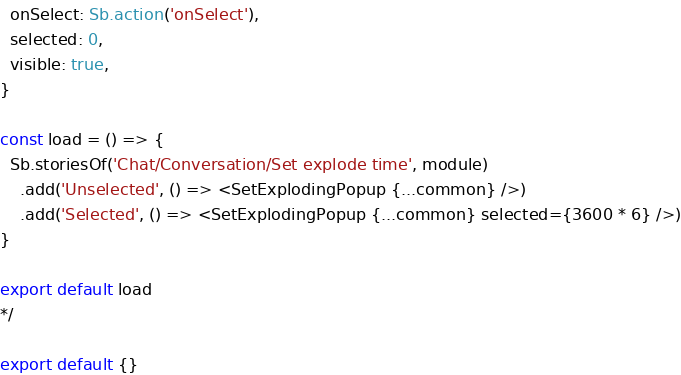<code> <loc_0><loc_0><loc_500><loc_500><_TypeScript_>  onSelect: Sb.action('onSelect'),
  selected: 0,
  visible: true,
}

const load = () => {
  Sb.storiesOf('Chat/Conversation/Set explode time', module)
    .add('Unselected', () => <SetExplodingPopup {...common} />)
    .add('Selected', () => <SetExplodingPopup {...common} selected={3600 * 6} />)
}

export default load
*/

export default {}
</code> 